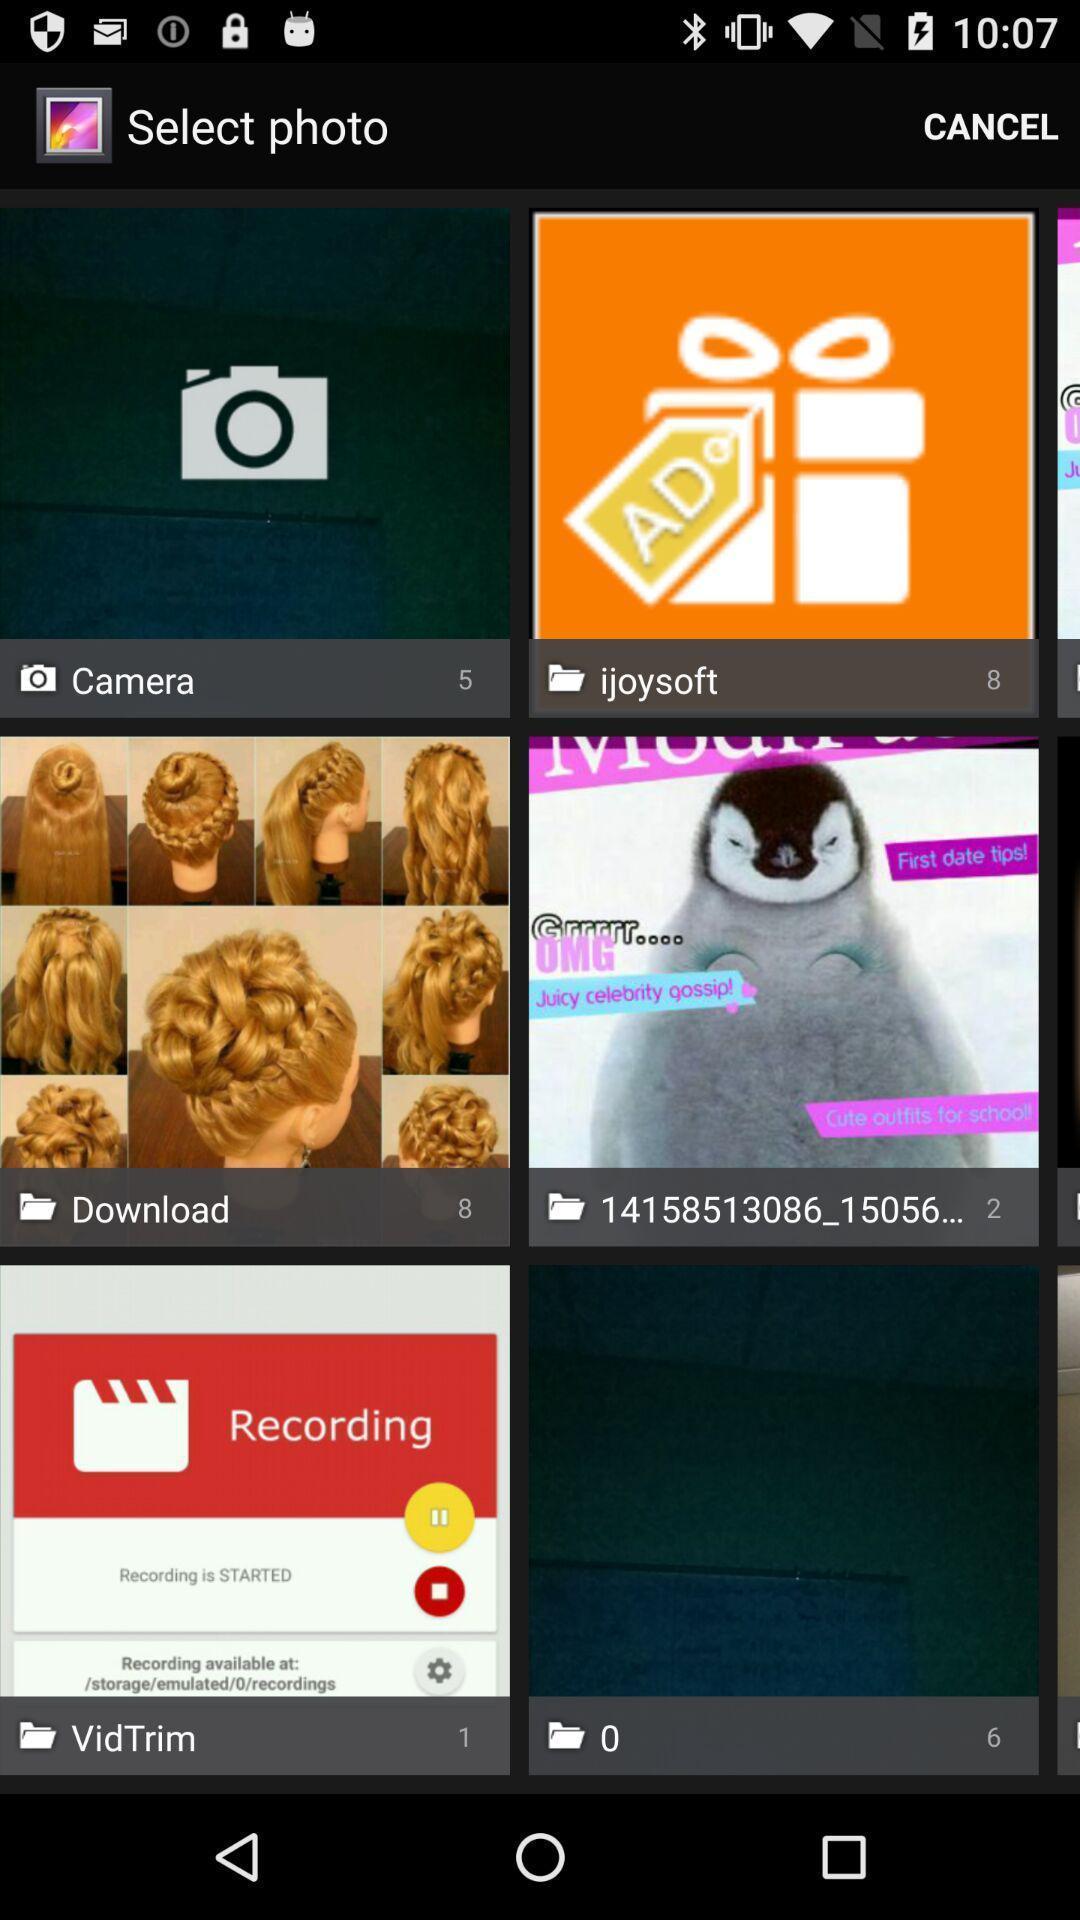Explain what's happening in this screen capture. Screen showing images to select. 